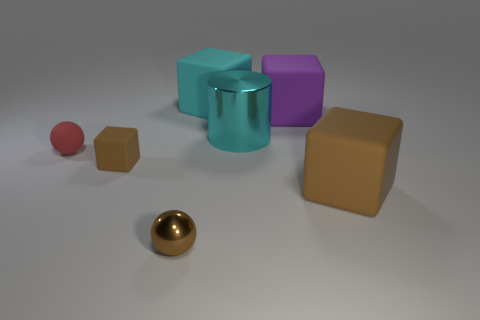Subtract all gray balls. Subtract all brown cylinders. How many balls are left? 2 Add 1 small brown matte blocks. How many objects exist? 8 Subtract all blocks. How many objects are left? 3 Subtract 0 purple spheres. How many objects are left? 7 Subtract all cyan rubber objects. Subtract all matte blocks. How many objects are left? 2 Add 5 red matte objects. How many red matte objects are left? 6 Add 4 large cyan things. How many large cyan things exist? 6 